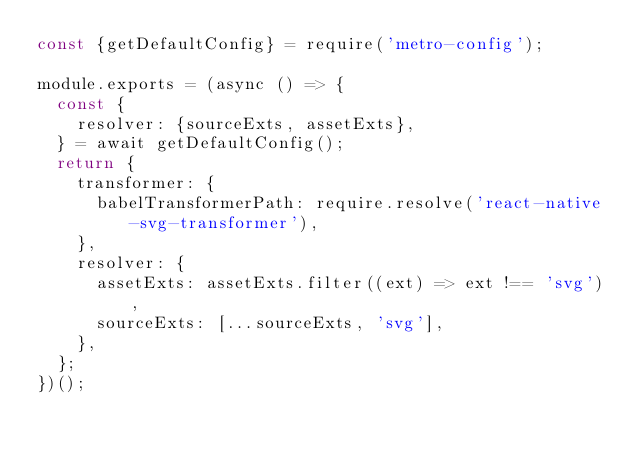Convert code to text. <code><loc_0><loc_0><loc_500><loc_500><_JavaScript_>const {getDefaultConfig} = require('metro-config');

module.exports = (async () => {
  const {
    resolver: {sourceExts, assetExts},
  } = await getDefaultConfig();
  return {
    transformer: {
      babelTransformerPath: require.resolve('react-native-svg-transformer'),
    },
    resolver: {
      assetExts: assetExts.filter((ext) => ext !== 'svg'),
      sourceExts: [...sourceExts, 'svg'],
    },
  };
})();
</code> 